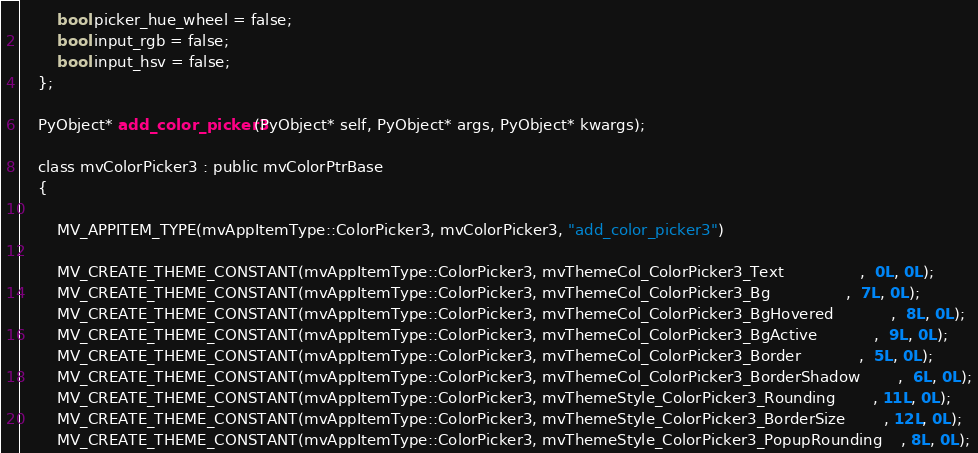Convert code to text. <code><loc_0><loc_0><loc_500><loc_500><_C_>		bool picker_hue_wheel = false;
		bool input_rgb = false;
		bool input_hsv = false;
	};

	PyObject* add_color_picker3(PyObject* self, PyObject* args, PyObject* kwargs);

	class mvColorPicker3 : public mvColorPtrBase
	{

		MV_APPITEM_TYPE(mvAppItemType::ColorPicker3, mvColorPicker3, "add_color_picker3")

		MV_CREATE_THEME_CONSTANT(mvAppItemType::ColorPicker3, mvThemeCol_ColorPicker3_Text				,  0L, 0L);
		MV_CREATE_THEME_CONSTANT(mvAppItemType::ColorPicker3, mvThemeCol_ColorPicker3_Bg				,  7L, 0L);
		MV_CREATE_THEME_CONSTANT(mvAppItemType::ColorPicker3, mvThemeCol_ColorPicker3_BgHovered			,  8L, 0L);
		MV_CREATE_THEME_CONSTANT(mvAppItemType::ColorPicker3, mvThemeCol_ColorPicker3_BgActive			,  9L, 0L);
		MV_CREATE_THEME_CONSTANT(mvAppItemType::ColorPicker3, mvThemeCol_ColorPicker3_Border			,  5L, 0L);
		MV_CREATE_THEME_CONSTANT(mvAppItemType::ColorPicker3, mvThemeCol_ColorPicker3_BorderShadow		,  6L, 0L);
		MV_CREATE_THEME_CONSTANT(mvAppItemType::ColorPicker3, mvThemeStyle_ColorPicker3_Rounding		, 11L, 0L);
		MV_CREATE_THEME_CONSTANT(mvAppItemType::ColorPicker3, mvThemeStyle_ColorPicker3_BorderSize		, 12L, 0L);
		MV_CREATE_THEME_CONSTANT(mvAppItemType::ColorPicker3, mvThemeStyle_ColorPicker3_PopupRounding	, 8L, 0L);</code> 